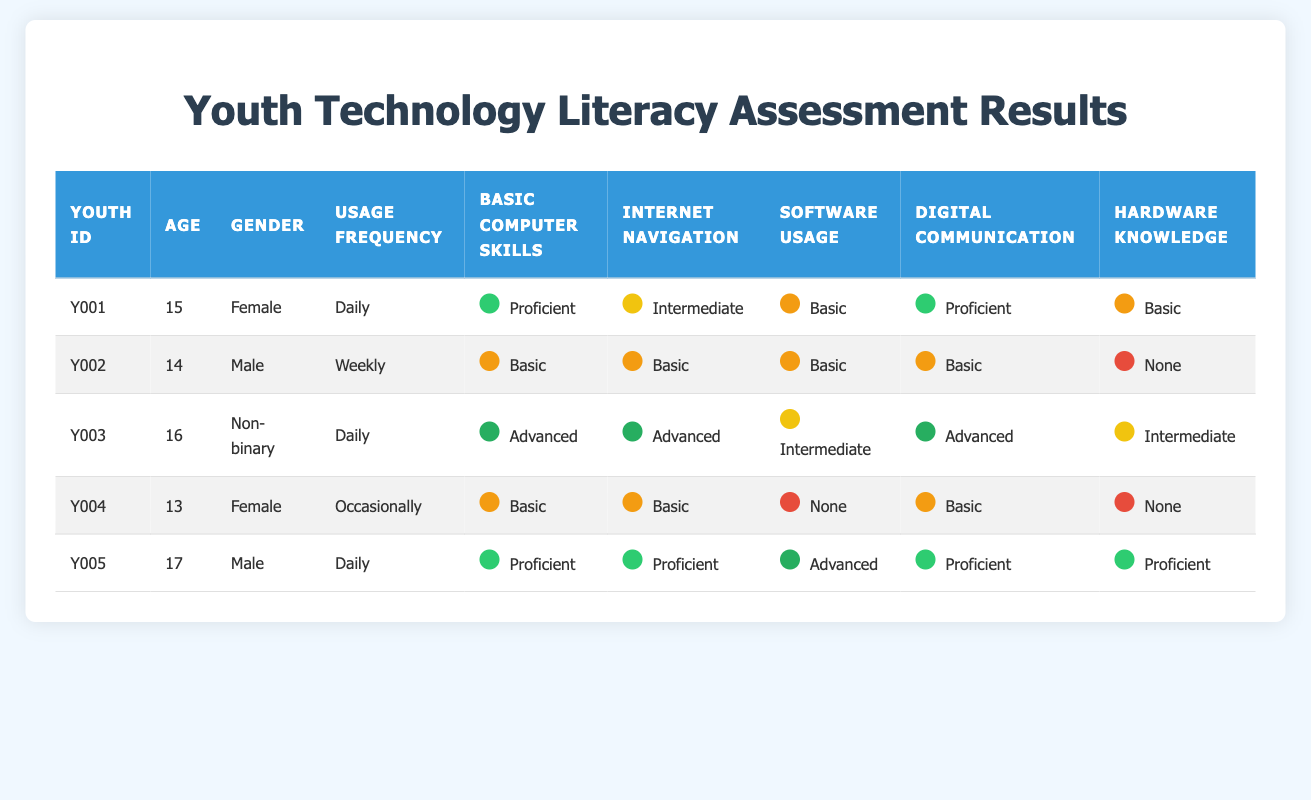What is the Technology Usage Frequency of Youth ID Y003? Referring to the table, the row for Youth ID Y003 indicates that this youth's Technology Usage Frequency is "Daily".
Answer: Daily How many youths have Proficient Basic Computer Skills? To find this, we look at the Basic Computer Skills column and count the instances marked as "Proficient". From the table: Youths Y001, Y005 have Proficient skills, giving us a total of 2.
Answer: 2 Is Youth ID Y004’s Hardware Knowledge classified as None? For Youth ID Y004, we can see in the Hardware Knowledge column that the classification is indeed marked as "None".
Answer: Yes What is the average age of the youths assessed? We need to sum the ages of all youths: 15 + 14 + 16 + 13 + 17 = 75. Then we divide this total by the number of youths, which is 5. So, the average age is 75/5 = 15.
Answer: 15 Which youth has the highest level of Digital Communication proficiency? Looking at the Digital Communication column, Youth ID Y003 and Y005 both have "Advanced" proficiency. However, Youth ID Y005 has even higher proficiency levels in other skill areas, signifying an overall strong proficiency. But for digital communication, it ties with Youth ID Y003.
Answer: Youth ID Y003 and Y005 How many youths reported Basic Software Usage skills? We check the Software Usage column for "Basic" classifications. The youths with Basic skills are Y001, Y002, and Y004. So, there are 3 youths.
Answer: 3 Does any youth use technology Daily and also have Advanced Internet Navigation skills? Examining the table, Youth ID Y003 (Daily usage and Advanced Internet Navigation) fits this criterion. Therefore, the answer is affirmative.
Answer: Yes What is the total count of youths that have None in Hardware Knowledge? We need to look through the Hardware Knowledge column and count: Youths Y002, Y004 both have "None". Therefore, there are 2 youths with none.
Answer: 2 What proportion of youths are Female? Out of 5 total youths listed, there are 2 females (Y001 and Y004). To find the proportion, we calculate 2/5 = 0.4 or 40%.
Answer: 40% 